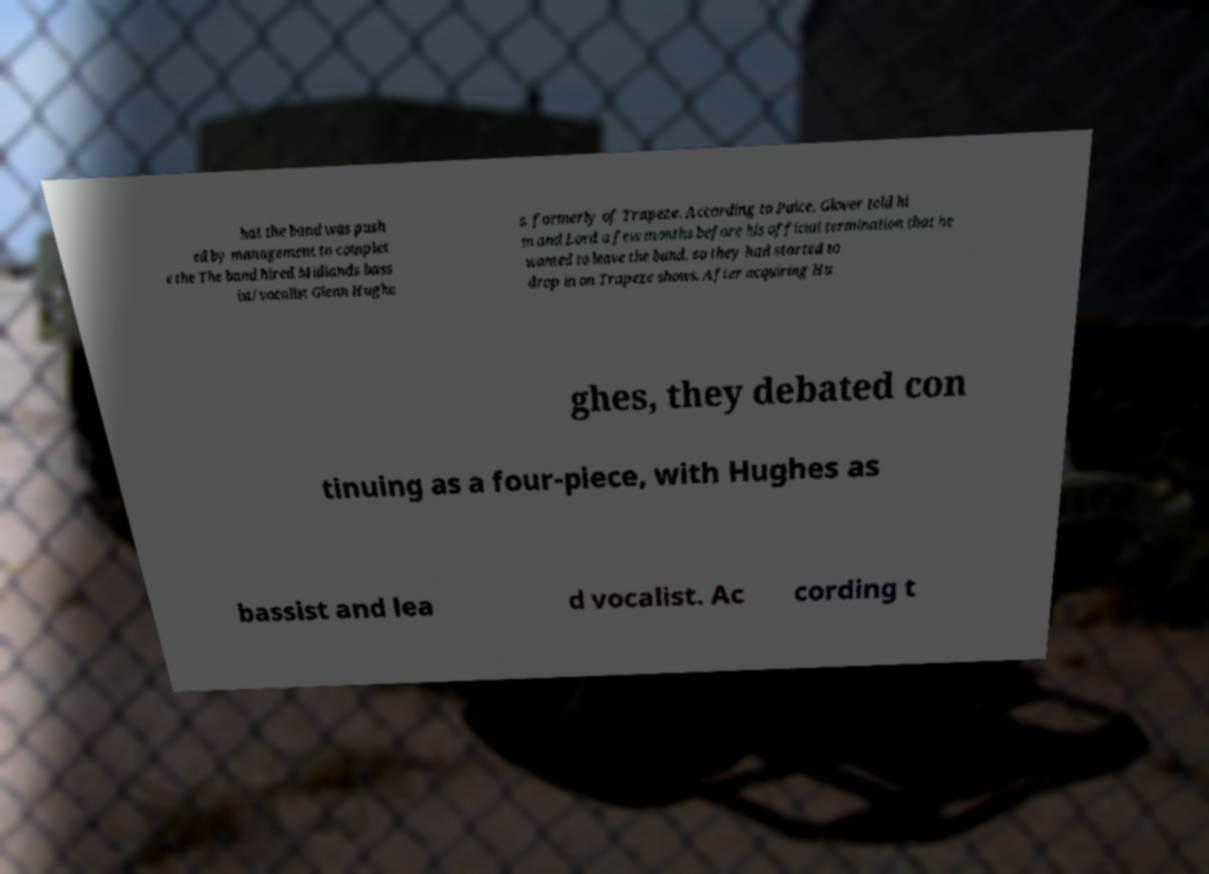Could you assist in decoding the text presented in this image and type it out clearly? hat the band was push ed by management to complet e the The band hired Midlands bass ist/vocalist Glenn Hughe s, formerly of Trapeze. According to Paice, Glover told hi m and Lord a few months before his official termination that he wanted to leave the band, so they had started to drop in on Trapeze shows. After acquiring Hu ghes, they debated con tinuing as a four-piece, with Hughes as bassist and lea d vocalist. Ac cording t 